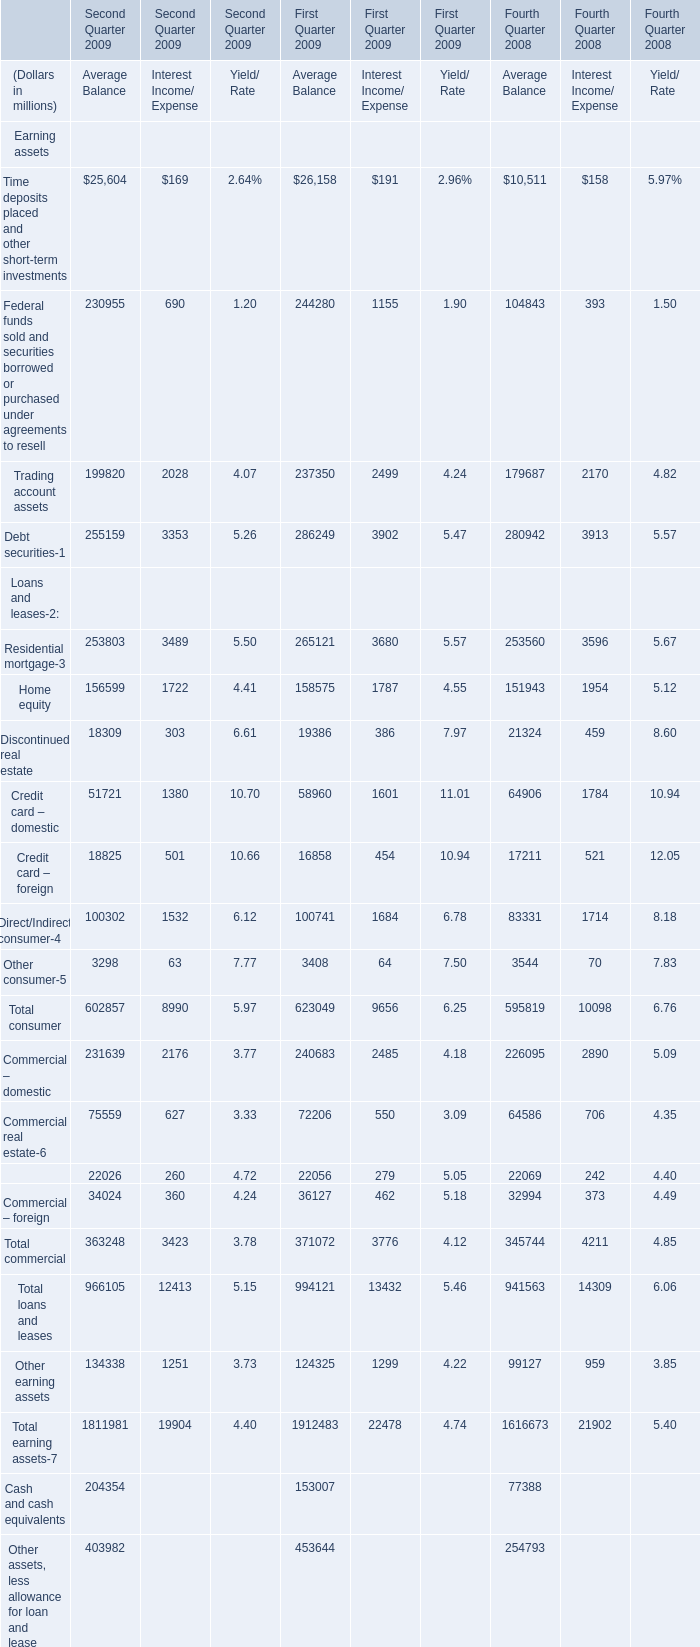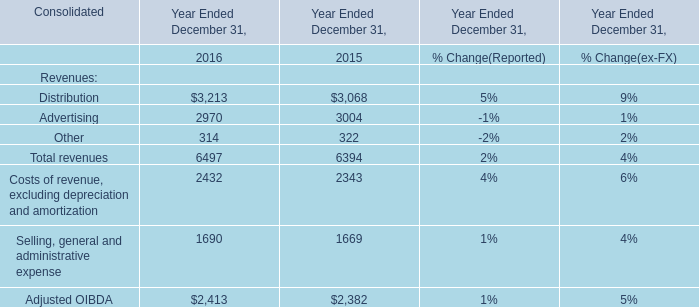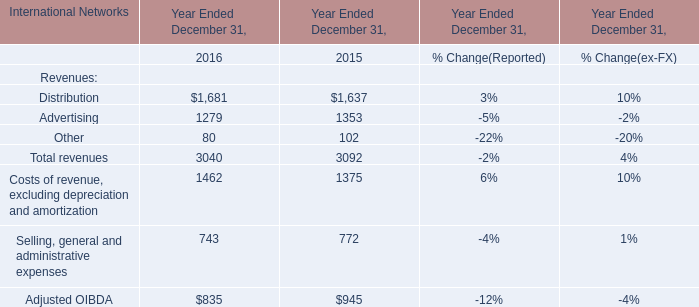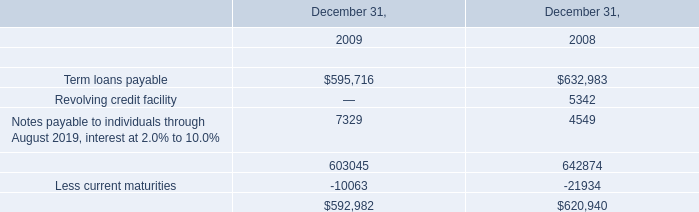What will Total assets reach in Third Quarter 2009 if it continues to grow at its current rate? (in million) 
Computations: (2420317 + ((2420317 * (2420317 - 2519134)) / 2519134))
Answer: 2325376.25251. 